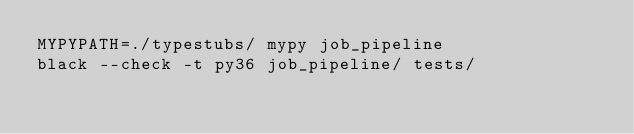Convert code to text. <code><loc_0><loc_0><loc_500><loc_500><_Bash_>MYPYPATH=./typestubs/ mypy job_pipeline
black --check -t py36 job_pipeline/ tests/
</code> 